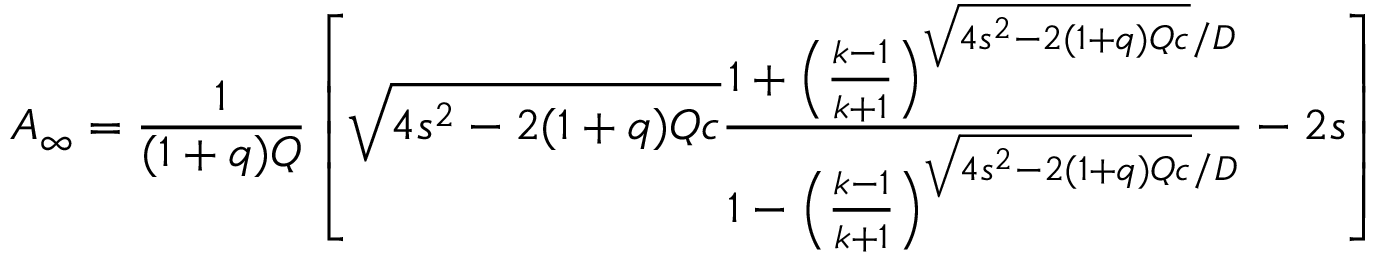Convert formula to latex. <formula><loc_0><loc_0><loc_500><loc_500>A _ { \infty } = \frac { 1 } { ( 1 + q ) Q } \left [ \sqrt { 4 s ^ { 2 } - 2 ( 1 + q ) Q c } \frac { 1 + \left ( \frac { k - 1 } { k + 1 } \right ) ^ { \sqrt { 4 s ^ { 2 } - 2 ( 1 + q ) Q c } / D } } { 1 - \left ( \frac { k - 1 } { k + 1 } \right ) ^ { \sqrt { 4 s ^ { 2 } - 2 ( 1 + q ) Q c } / D } } - 2 s \right ]</formula> 